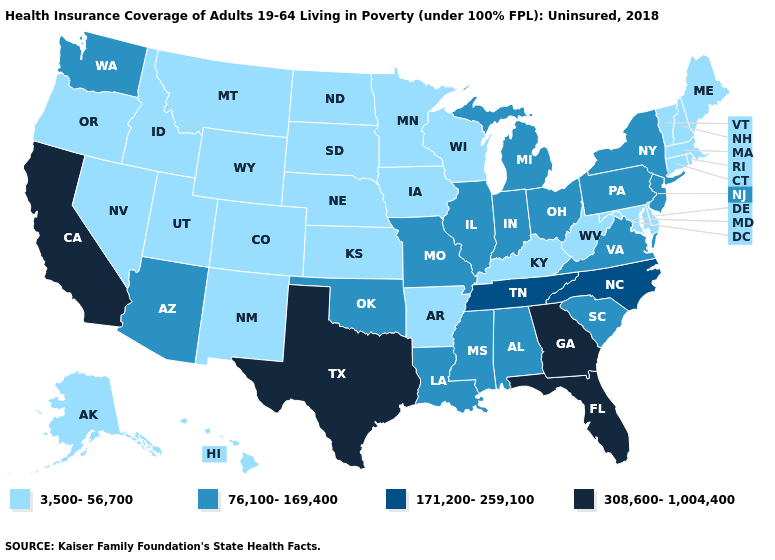Name the states that have a value in the range 76,100-169,400?
Concise answer only. Alabama, Arizona, Illinois, Indiana, Louisiana, Michigan, Mississippi, Missouri, New Jersey, New York, Ohio, Oklahoma, Pennsylvania, South Carolina, Virginia, Washington. Name the states that have a value in the range 76,100-169,400?
Answer briefly. Alabama, Arizona, Illinois, Indiana, Louisiana, Michigan, Mississippi, Missouri, New Jersey, New York, Ohio, Oklahoma, Pennsylvania, South Carolina, Virginia, Washington. What is the value of New York?
Be succinct. 76,100-169,400. Does Wisconsin have the highest value in the USA?
Give a very brief answer. No. Name the states that have a value in the range 171,200-259,100?
Be succinct. North Carolina, Tennessee. Which states hav the highest value in the South?
Give a very brief answer. Florida, Georgia, Texas. Does Illinois have the lowest value in the USA?
Answer briefly. No. What is the lowest value in the West?
Keep it brief. 3,500-56,700. Name the states that have a value in the range 171,200-259,100?
Write a very short answer. North Carolina, Tennessee. What is the highest value in the MidWest ?
Quick response, please. 76,100-169,400. Does Michigan have the highest value in the MidWest?
Short answer required. Yes. How many symbols are there in the legend?
Concise answer only. 4. Name the states that have a value in the range 3,500-56,700?
Be succinct. Alaska, Arkansas, Colorado, Connecticut, Delaware, Hawaii, Idaho, Iowa, Kansas, Kentucky, Maine, Maryland, Massachusetts, Minnesota, Montana, Nebraska, Nevada, New Hampshire, New Mexico, North Dakota, Oregon, Rhode Island, South Dakota, Utah, Vermont, West Virginia, Wisconsin, Wyoming. Name the states that have a value in the range 76,100-169,400?
Quick response, please. Alabama, Arizona, Illinois, Indiana, Louisiana, Michigan, Mississippi, Missouri, New Jersey, New York, Ohio, Oklahoma, Pennsylvania, South Carolina, Virginia, Washington. Which states hav the highest value in the Northeast?
Give a very brief answer. New Jersey, New York, Pennsylvania. 